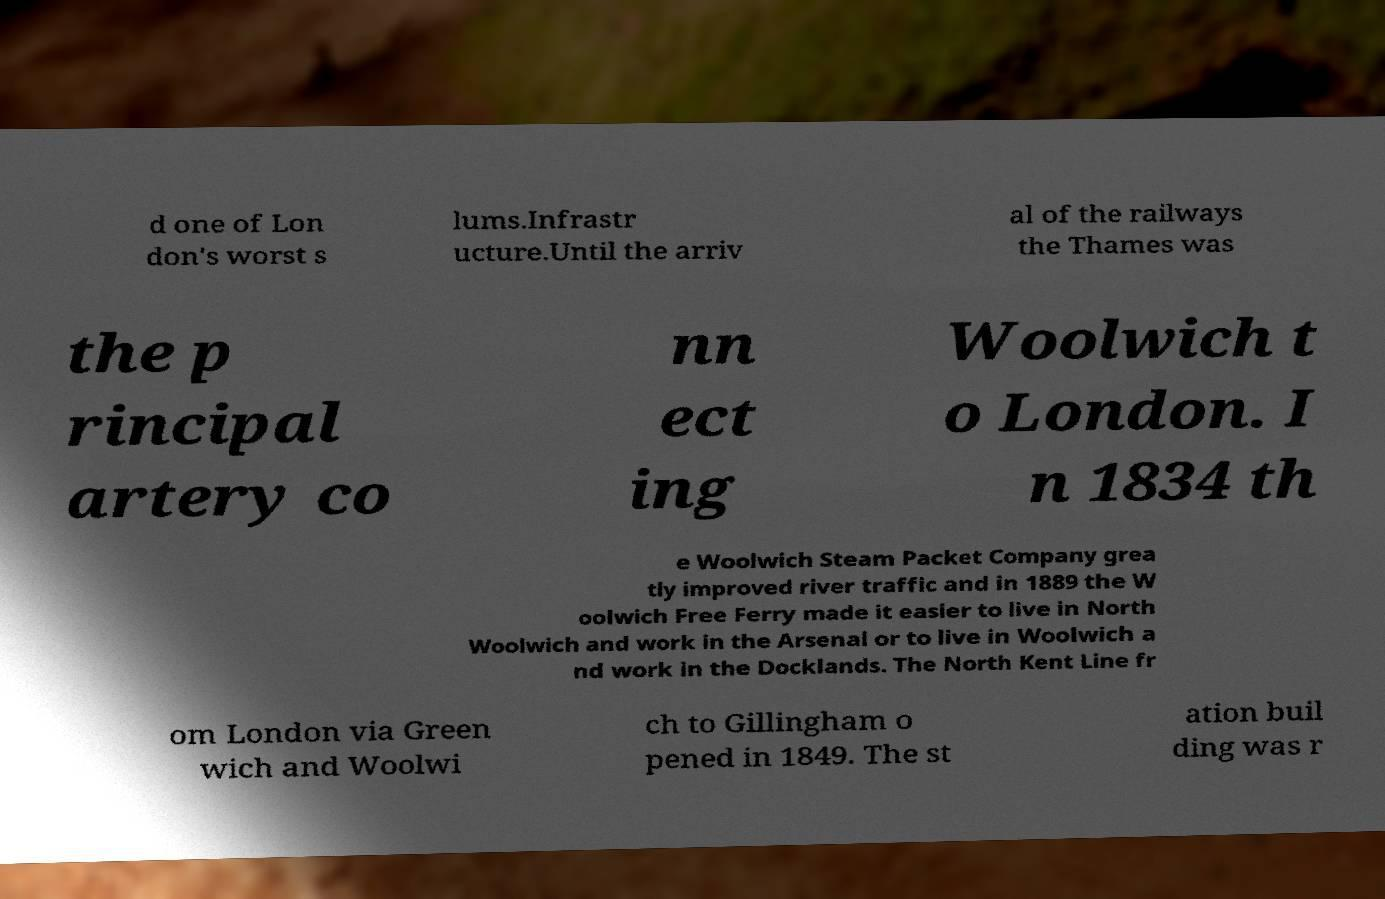What messages or text are displayed in this image? I need them in a readable, typed format. d one of Lon don's worst s lums.Infrastr ucture.Until the arriv al of the railways the Thames was the p rincipal artery co nn ect ing Woolwich t o London. I n 1834 th e Woolwich Steam Packet Company grea tly improved river traffic and in 1889 the W oolwich Free Ferry made it easier to live in North Woolwich and work in the Arsenal or to live in Woolwich a nd work in the Docklands. The North Kent Line fr om London via Green wich and Woolwi ch to Gillingham o pened in 1849. The st ation buil ding was r 